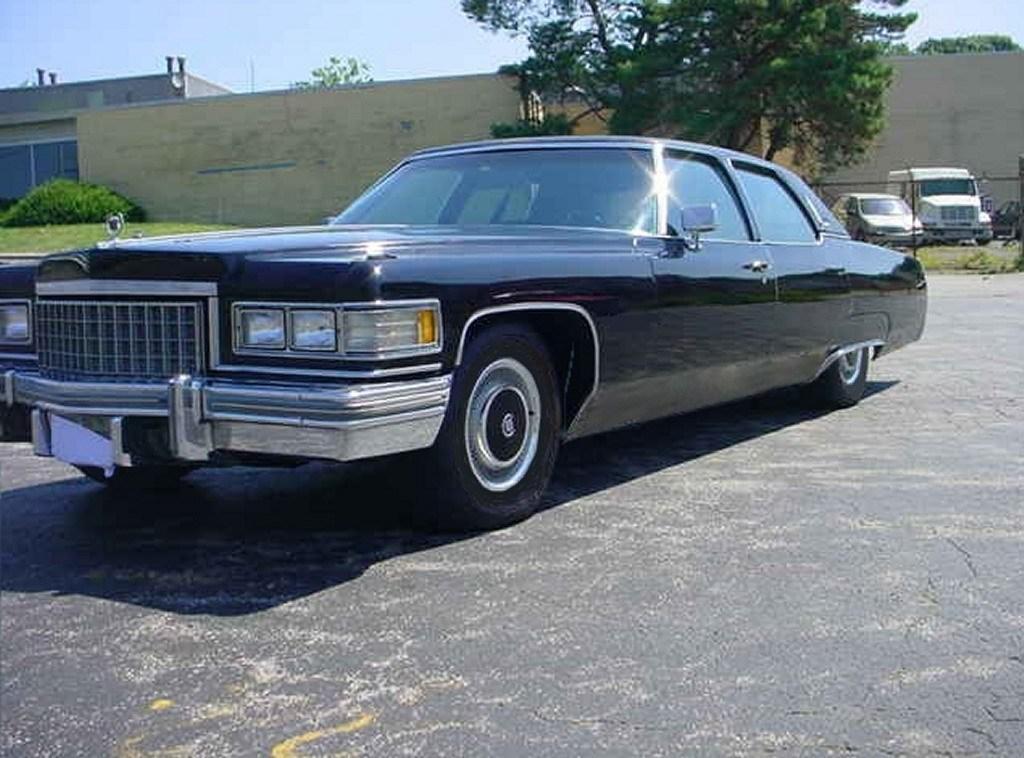Please provide a concise description of this image. This picture is taken on the wide road and it is sunny. In this image, in the middle, we can see car which is in black color. In the background, we can see some cars, vehicle, trees, wall, plants, building, glass window, trees. At the top, we can see a sky, at the bottom, we can see a grass and a land. 